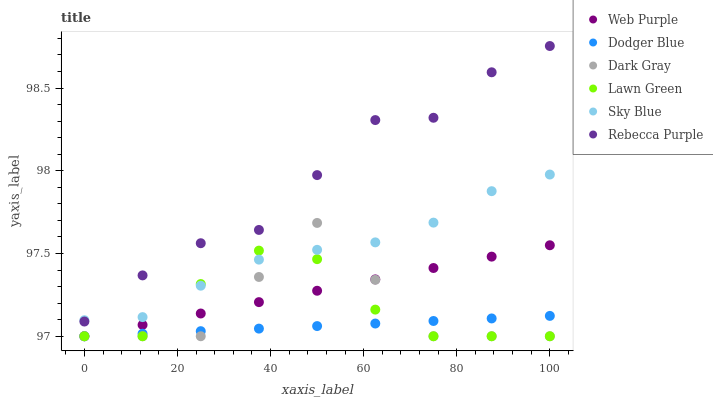Does Dodger Blue have the minimum area under the curve?
Answer yes or no. Yes. Does Rebecca Purple have the maximum area under the curve?
Answer yes or no. Yes. Does Dark Gray have the minimum area under the curve?
Answer yes or no. No. Does Dark Gray have the maximum area under the curve?
Answer yes or no. No. Is Dodger Blue the smoothest?
Answer yes or no. Yes. Is Dark Gray the roughest?
Answer yes or no. Yes. Is Web Purple the smoothest?
Answer yes or no. No. Is Web Purple the roughest?
Answer yes or no. No. Does Lawn Green have the lowest value?
Answer yes or no. Yes. Does Rebecca Purple have the lowest value?
Answer yes or no. No. Does Rebecca Purple have the highest value?
Answer yes or no. Yes. Does Dark Gray have the highest value?
Answer yes or no. No. Is Dodger Blue less than Rebecca Purple?
Answer yes or no. Yes. Is Rebecca Purple greater than Dark Gray?
Answer yes or no. Yes. Does Dark Gray intersect Web Purple?
Answer yes or no. Yes. Is Dark Gray less than Web Purple?
Answer yes or no. No. Is Dark Gray greater than Web Purple?
Answer yes or no. No. Does Dodger Blue intersect Rebecca Purple?
Answer yes or no. No. 